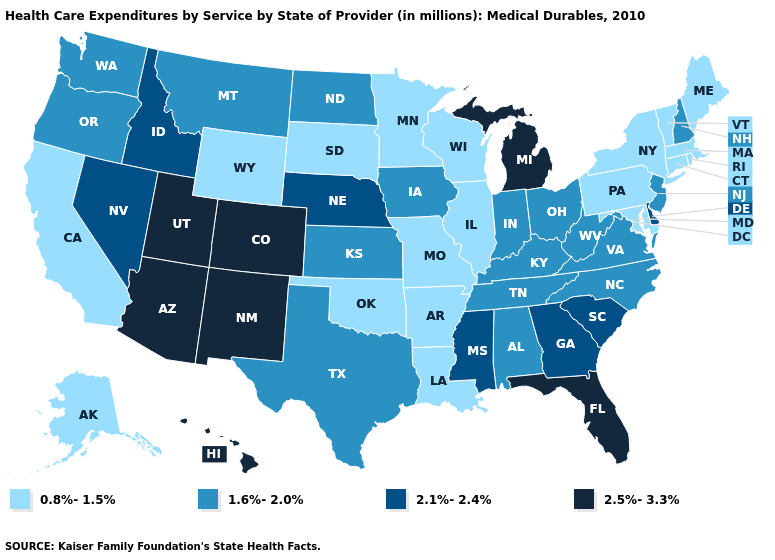What is the highest value in the West ?
Answer briefly. 2.5%-3.3%. Name the states that have a value in the range 2.5%-3.3%?
Write a very short answer. Arizona, Colorado, Florida, Hawaii, Michigan, New Mexico, Utah. Name the states that have a value in the range 2.5%-3.3%?
Keep it brief. Arizona, Colorado, Florida, Hawaii, Michigan, New Mexico, Utah. Which states have the lowest value in the USA?
Quick response, please. Alaska, Arkansas, California, Connecticut, Illinois, Louisiana, Maine, Maryland, Massachusetts, Minnesota, Missouri, New York, Oklahoma, Pennsylvania, Rhode Island, South Dakota, Vermont, Wisconsin, Wyoming. Does Minnesota have the same value as Alabama?
Concise answer only. No. Does Iowa have the lowest value in the MidWest?
Be succinct. No. Does the map have missing data?
Write a very short answer. No. What is the value of Wyoming?
Keep it brief. 0.8%-1.5%. Name the states that have a value in the range 2.5%-3.3%?
Be succinct. Arizona, Colorado, Florida, Hawaii, Michigan, New Mexico, Utah. Does Pennsylvania have the lowest value in the USA?
Keep it brief. Yes. Does Idaho have the lowest value in the USA?
Give a very brief answer. No. What is the value of Nevada?
Answer briefly. 2.1%-2.4%. Name the states that have a value in the range 0.8%-1.5%?
Concise answer only. Alaska, Arkansas, California, Connecticut, Illinois, Louisiana, Maine, Maryland, Massachusetts, Minnesota, Missouri, New York, Oklahoma, Pennsylvania, Rhode Island, South Dakota, Vermont, Wisconsin, Wyoming. Is the legend a continuous bar?
Give a very brief answer. No. What is the lowest value in the West?
Be succinct. 0.8%-1.5%. 